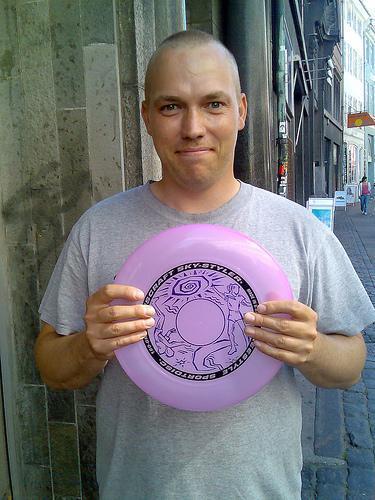How many people are in the picture?
Give a very brief answer. 1. 